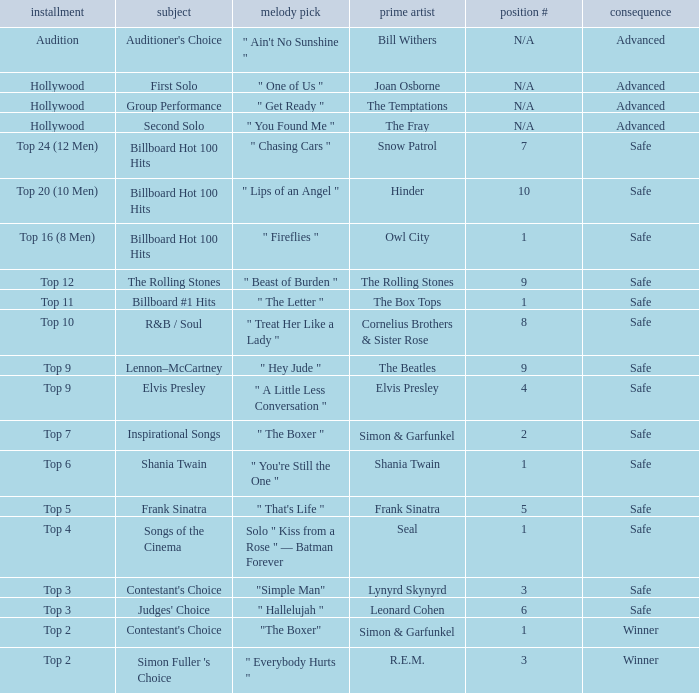The theme Auditioner's Choice	has what song choice? " Ain't No Sunshine ". 